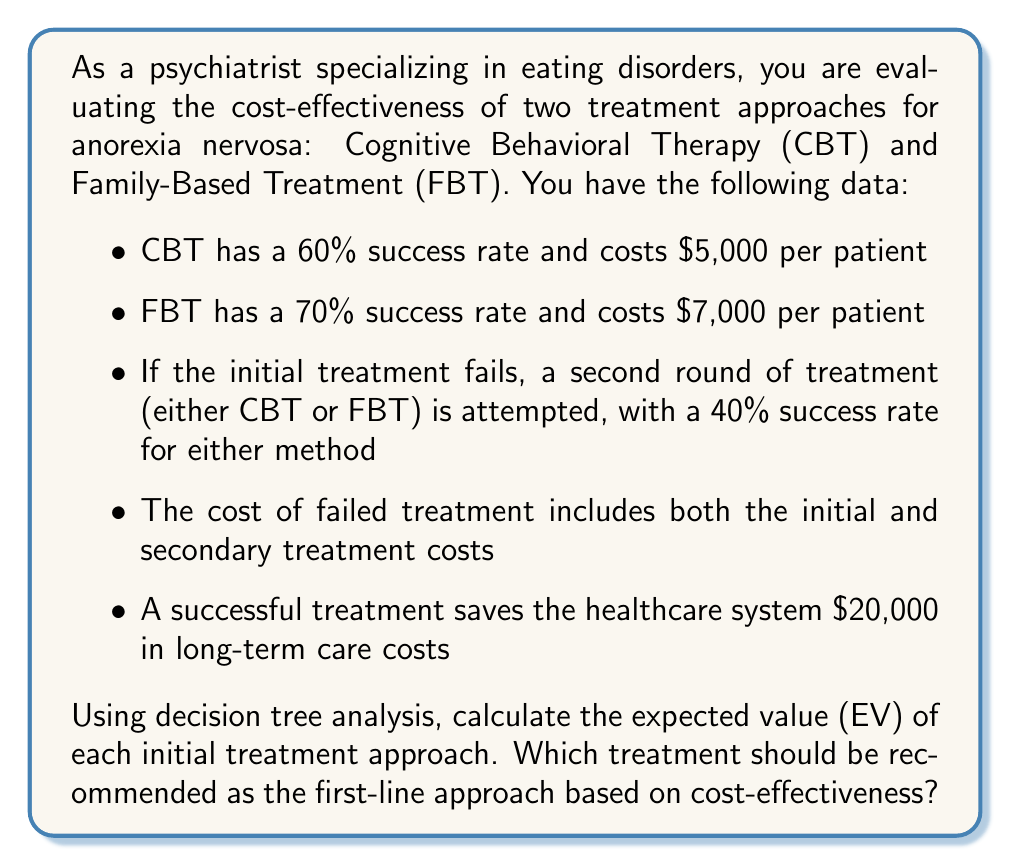Teach me how to tackle this problem. To solve this problem, we need to construct a decision tree and calculate the expected value for each initial treatment approach. Let's break it down step-by-step:

1. Construct the decision tree:

[asy]
unitsize(1cm);

draw((0,0)--(2,1), arrow=Arrow);
draw((0,0)--(2,-1), arrow=Arrow);

draw((2,1)--(4,1.5), arrow=Arrow);
draw((2,1)--(4,0.5), arrow=Arrow);
draw((2,-1)--(4,-0.5), arrow=Arrow);
draw((2,-1)--(4,-1.5), arrow=Arrow);

draw((4,0.5)--(6,0.75), arrow=Arrow);
draw((4,0.5)--(6,0.25), arrow=Arrow);
draw((4,-0.5)--(6,-0.25), arrow=Arrow);
draw((4,-0.5)--(6,-0.75), arrow=Arrow);

label("CBT", (1,0.5));
label("FBT", (1,-0.5));

label("Success (60%)", (3,1.25));
label("Fail (40%)", (3,0.75));
label("Success (70%)", (3,-0.75));
label("Fail (30%)", (3,-1.25));

label("Success (40%)", (5,0.625));
label("Fail (60%)", (5,0.375));
label("Success (40%)", (5,-0.375));
label("Fail (60%)", (5,-0.625));

[/asy]

2. Calculate the probabilities and outcomes for each branch:

For CBT:
- Success: $P = 0.60$, Outcome = $20,000 - 5,000 = $15,000
- Fail then Success: $P = 0.40 * 0.40 = 0.16$, Outcome = $20,000 - 5,000 - 5,000 = $10,000
- Fail then Fail: $P = 0.40 * 0.60 = 0.24$, Outcome = $-5,000 - 5,000 = -$10,000

For FBT:
- Success: $P = 0.70$, Outcome = $20,000 - 7,000 = $13,000
- Fail then Success: $P = 0.30 * 0.40 = 0.12$, Outcome = $20,000 - 7,000 - 5,000 = $8,000
- Fail then Fail: $P = 0.30 * 0.60 = 0.18$, Outcome = $-7,000 - 5,000 = -$12,000

3. Calculate the expected value for each initial treatment:

For CBT:
$EV_{CBT} = (0.60 * 15,000) + (0.16 * 10,000) + (0.24 * (-10,000))$
$EV_{CBT} = 9,000 + 1,600 - 2,400 = $8,200

For FBT:
$EV_{FBT} = (0.70 * 13,000) + (0.12 * 8,000) + (0.18 * (-12,000))$
$EV_{FBT} = 9,100 + 960 - 2,160 = $7,900

4. Compare the expected values:

CBT has a higher expected value ($8,200) compared to FBT ($7,900).
Answer: The expected value for CBT is $8,200, and for FBT is $7,900. Based on cost-effectiveness, Cognitive Behavioral Therapy (CBT) should be recommended as the first-line approach for treating anorexia nervosa. 